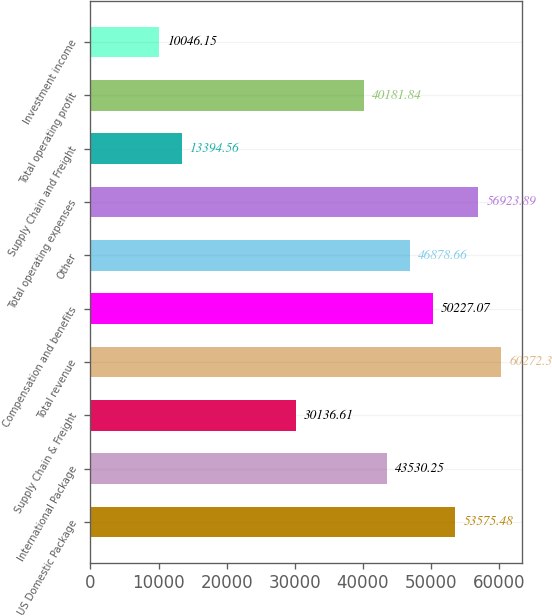<chart> <loc_0><loc_0><loc_500><loc_500><bar_chart><fcel>US Domestic Package<fcel>International Package<fcel>Supply Chain & Freight<fcel>Total revenue<fcel>Compensation and benefits<fcel>Other<fcel>Total operating expenses<fcel>Supply Chain and Freight<fcel>Total operating profit<fcel>Investment income<nl><fcel>53575.5<fcel>43530.2<fcel>30136.6<fcel>60272.3<fcel>50227.1<fcel>46878.7<fcel>56923.9<fcel>13394.6<fcel>40181.8<fcel>10046.1<nl></chart> 